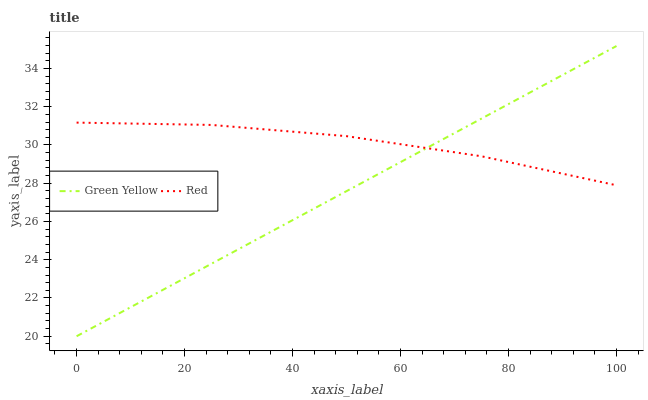Does Green Yellow have the minimum area under the curve?
Answer yes or no. Yes. Does Red have the maximum area under the curve?
Answer yes or no. Yes. Does Red have the minimum area under the curve?
Answer yes or no. No. Is Green Yellow the smoothest?
Answer yes or no. Yes. Is Red the roughest?
Answer yes or no. Yes. Is Red the smoothest?
Answer yes or no. No. Does Green Yellow have the lowest value?
Answer yes or no. Yes. Does Red have the lowest value?
Answer yes or no. No. Does Green Yellow have the highest value?
Answer yes or no. Yes. Does Red have the highest value?
Answer yes or no. No. Does Green Yellow intersect Red?
Answer yes or no. Yes. Is Green Yellow less than Red?
Answer yes or no. No. Is Green Yellow greater than Red?
Answer yes or no. No. 